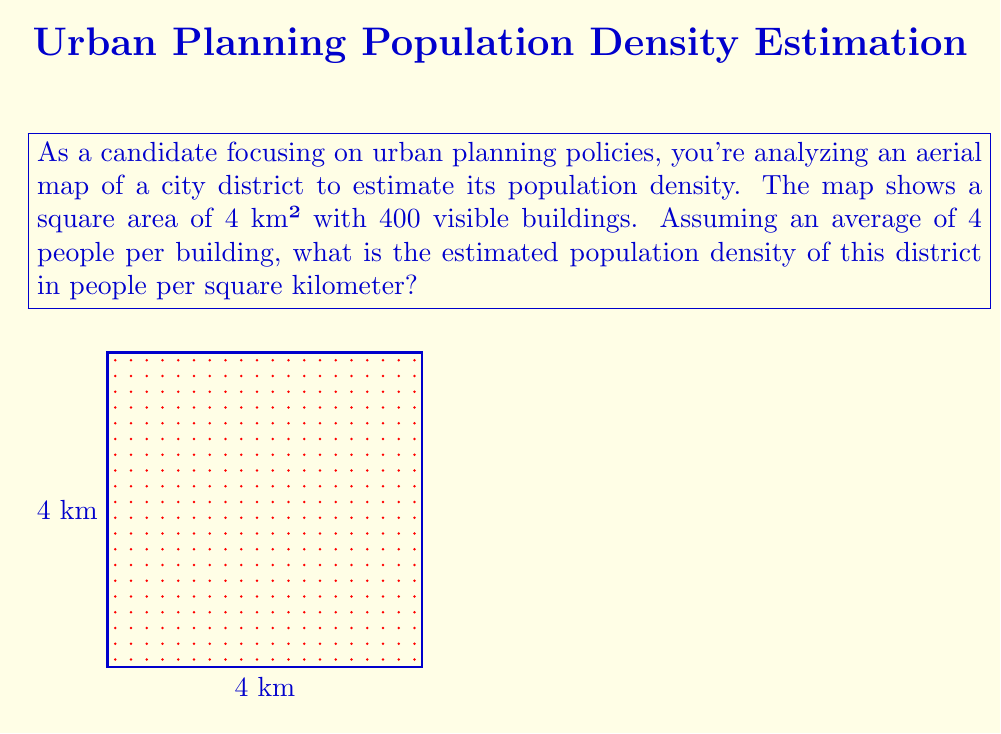Help me with this question. To solve this problem, we'll follow these steps:

1) First, let's identify the given information:
   - Area of the district: 4 km²
   - Number of buildings: 400
   - Average number of people per building: 4

2) Calculate the total estimated population:
   $$\text{Total population} = \text{Number of buildings} \times \text{Average people per building}$$
   $$\text{Total population} = 400 \times 4 = 1,600 \text{ people}$$

3) Now, we can calculate the population density using the formula:
   $$\text{Population density} = \frac{\text{Total population}}{\text{Area}}$$

4) Substituting our values:
   $$\text{Population density} = \frac{1,600 \text{ people}}{4 \text{ km}^2}$$

5) Simplify:
   $$\text{Population density} = 400 \text{ people/km}^2$$

Therefore, the estimated population density of this district is 400 people per square kilometer.
Answer: 400 people/km² 